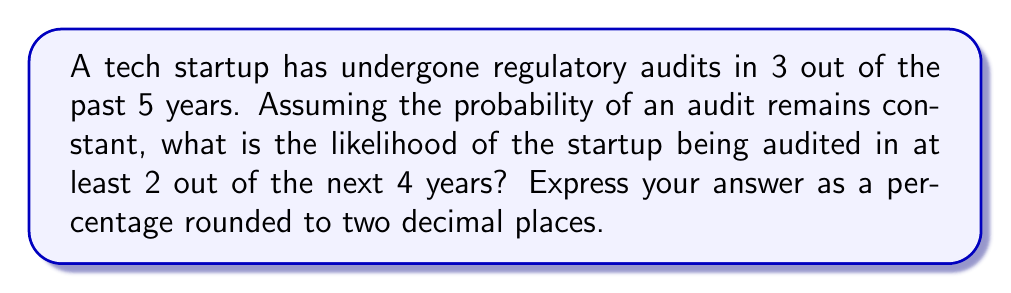Could you help me with this problem? Let's approach this step-by-step using the binomial probability distribution:

1) First, we need to estimate the probability of an audit in any given year:
   $p = \frac{3}{5} = 0.6$

2) We want the probability of at least 2 audits in 4 years. This is equivalent to 1 minus the probability of 0 or 1 audit in 4 years.

3) The binomial probability formula is:
   $P(X = k) = \binom{n}{k} p^k (1-p)^{n-k}$
   where n is the number of trials, k is the number of successes, p is the probability of success on each trial.

4) Probability of exactly 0 audits in 4 years:
   $P(X = 0) = \binom{4}{0} (0.6)^0 (0.4)^4 = 1 \cdot 1 \cdot 0.0256 = 0.0256$

5) Probability of exactly 1 audit in 4 years:
   $P(X = 1) = \binom{4}{1} (0.6)^1 (0.4)^3 = 4 \cdot 0.6 \cdot 0.064 = 0.1536$

6) Probability of 0 or 1 audit:
   $P(X \leq 1) = 0.0256 + 0.1536 = 0.1792$

7) Therefore, the probability of at least 2 audits is:
   $P(X \geq 2) = 1 - P(X \leq 1) = 1 - 0.1792 = 0.8208$

8) Converting to a percentage and rounding to two decimal places:
   $0.8208 \cdot 100 \approx 82.08\%$
Answer: 82.08% 